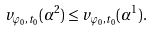Convert formula to latex. <formula><loc_0><loc_0><loc_500><loc_500>v _ { \varphi _ { 0 } , t _ { 0 } } ( \alpha ^ { 2 } ) \leq v _ { \varphi _ { 0 } , t _ { 0 } } ( \alpha ^ { 1 } ) .</formula> 